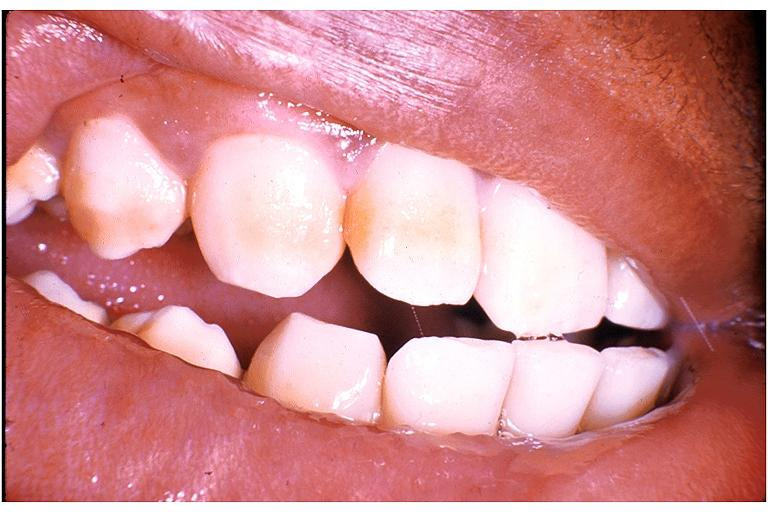does this image show fluorosis?
Answer the question using a single word or phrase. Yes 